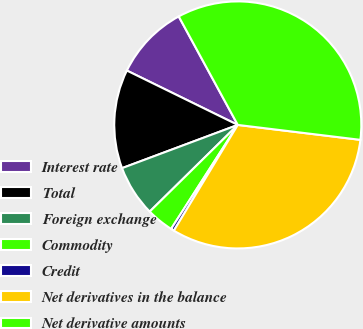Convert chart. <chart><loc_0><loc_0><loc_500><loc_500><pie_chart><fcel>Interest rate<fcel>Total<fcel>Foreign exchange<fcel>Commodity<fcel>Credit<fcel>Net derivatives in the balance<fcel>Net derivative amounts<nl><fcel>9.81%<fcel>12.94%<fcel>6.68%<fcel>3.55%<fcel>0.42%<fcel>31.72%<fcel>34.85%<nl></chart> 